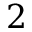Convert formula to latex. <formula><loc_0><loc_0><loc_500><loc_500>2</formula> 